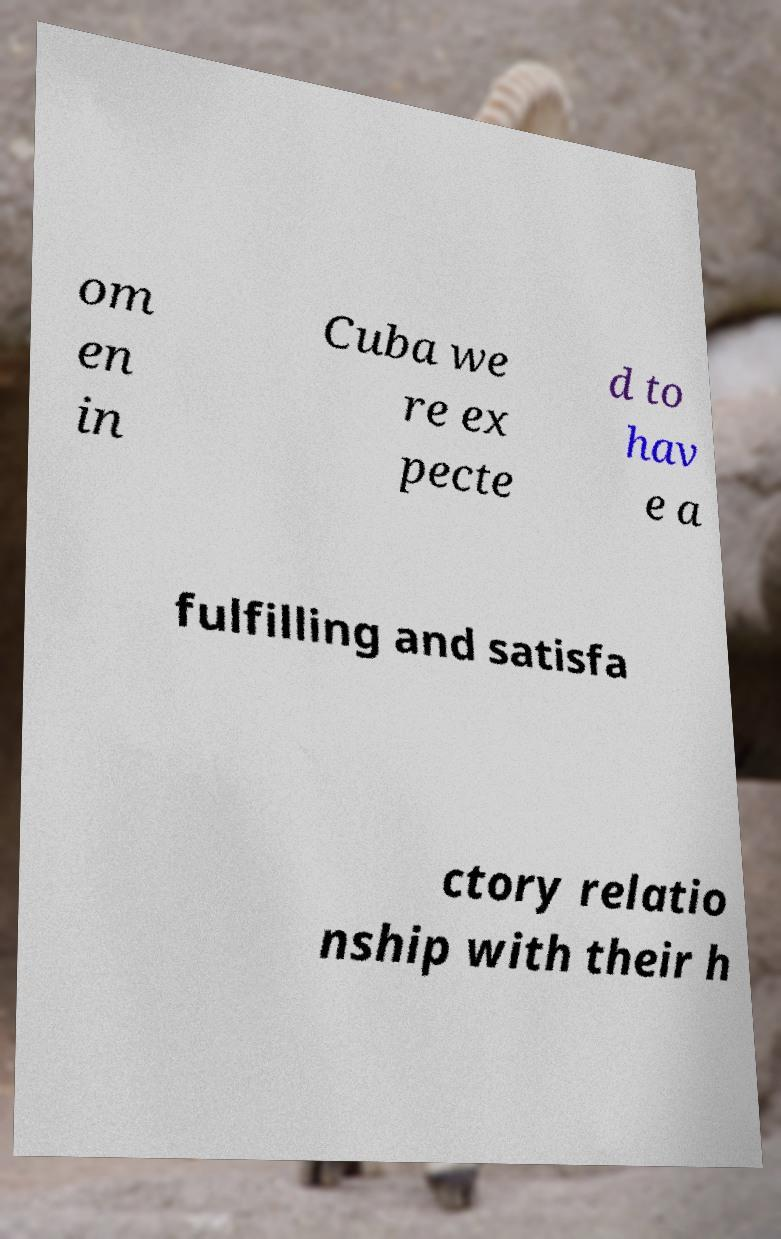Can you accurately transcribe the text from the provided image for me? om en in Cuba we re ex pecte d to hav e a fulfilling and satisfa ctory relatio nship with their h 